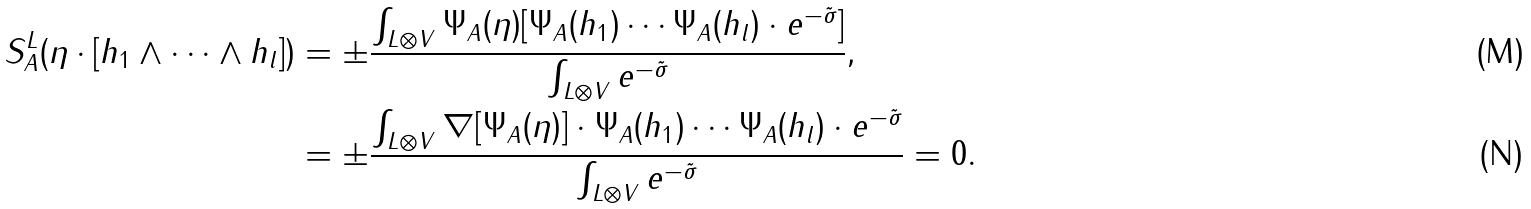<formula> <loc_0><loc_0><loc_500><loc_500>S _ { A } ^ { L } ( \eta \cdot [ h _ { 1 } \wedge \cdots \wedge h _ { l } ] ) & = \pm \frac { \int _ { L \otimes V } \Psi _ { A } ( \eta ) [ \Psi _ { A } ( h _ { 1 } ) \cdots \Psi _ { A } ( h _ { l } ) \cdot e ^ { - \tilde { \sigma } } ] } { \int _ { L \otimes V } e ^ { - \tilde { \sigma } } } , \\ & = \pm \frac { \int _ { L \otimes V } \nabla [ \Psi _ { A } ( \eta ) ] \cdot \Psi _ { A } ( h _ { 1 } ) \cdots \Psi _ { A } ( h _ { l } ) \cdot e ^ { - \tilde { \sigma } } } { \int _ { L \otimes V } e ^ { - \tilde { \sigma } } } = 0 .</formula> 